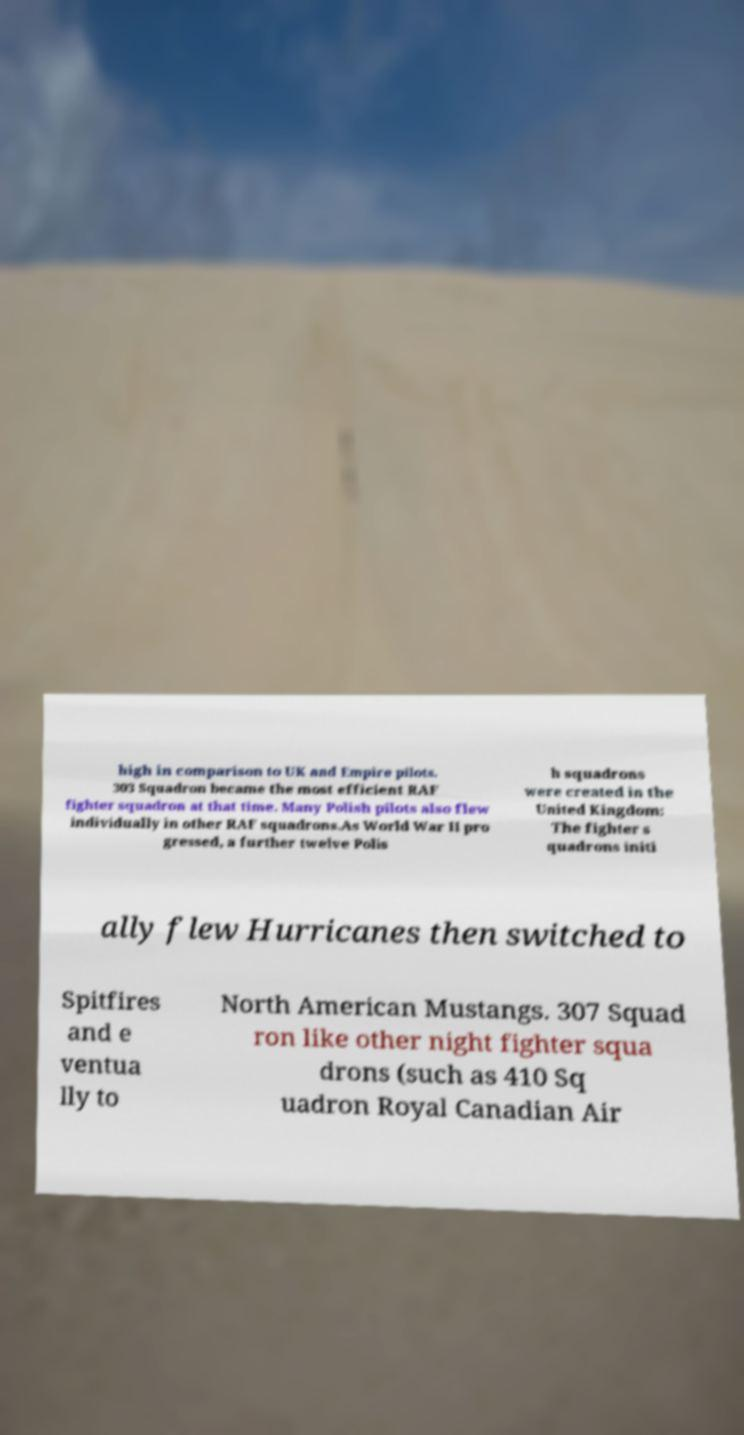Please read and relay the text visible in this image. What does it say? high in comparison to UK and Empire pilots. 303 Squadron became the most efficient RAF fighter squadron at that time. Many Polish pilots also flew individually in other RAF squadrons.As World War II pro gressed, a further twelve Polis h squadrons were created in the United Kingdom: The fighter s quadrons initi ally flew Hurricanes then switched to Spitfires and e ventua lly to North American Mustangs. 307 Squad ron like other night fighter squa drons (such as 410 Sq uadron Royal Canadian Air 